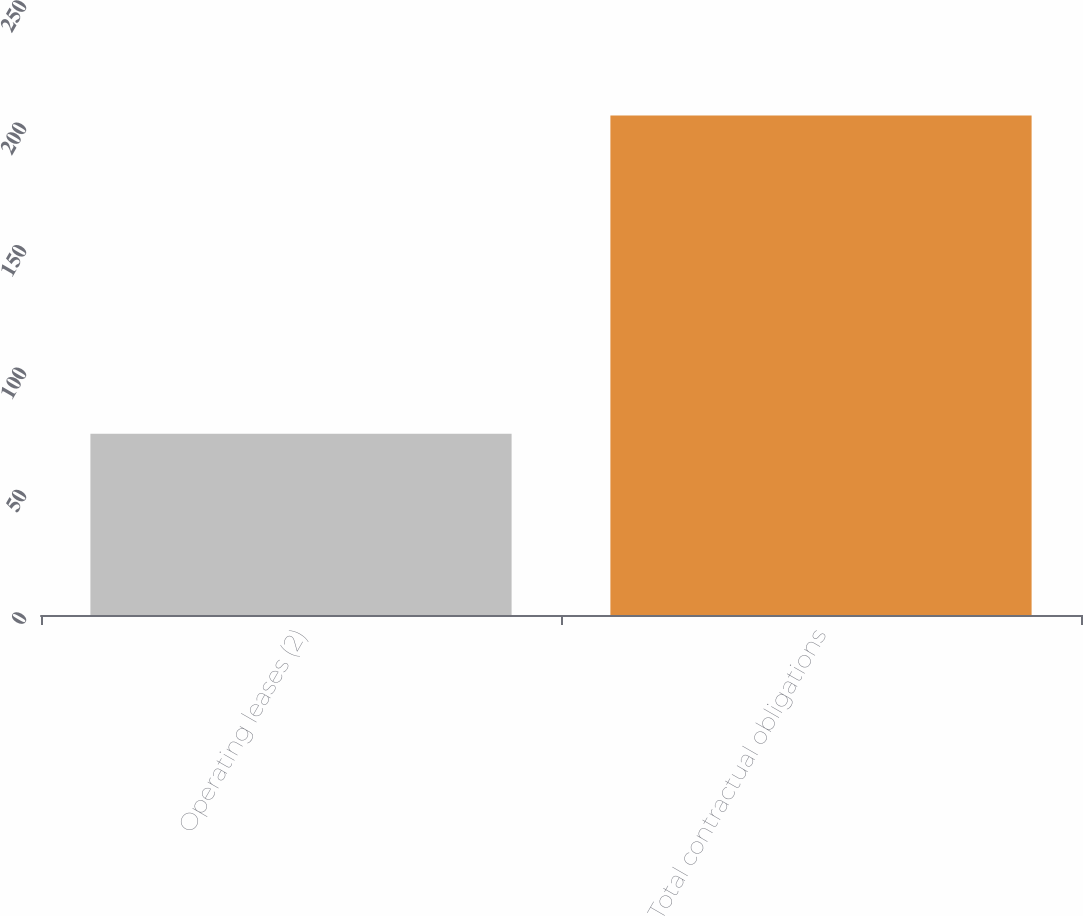Convert chart. <chart><loc_0><loc_0><loc_500><loc_500><bar_chart><fcel>Operating leases (2)<fcel>Total contractual obligations<nl><fcel>74<fcel>204<nl></chart> 